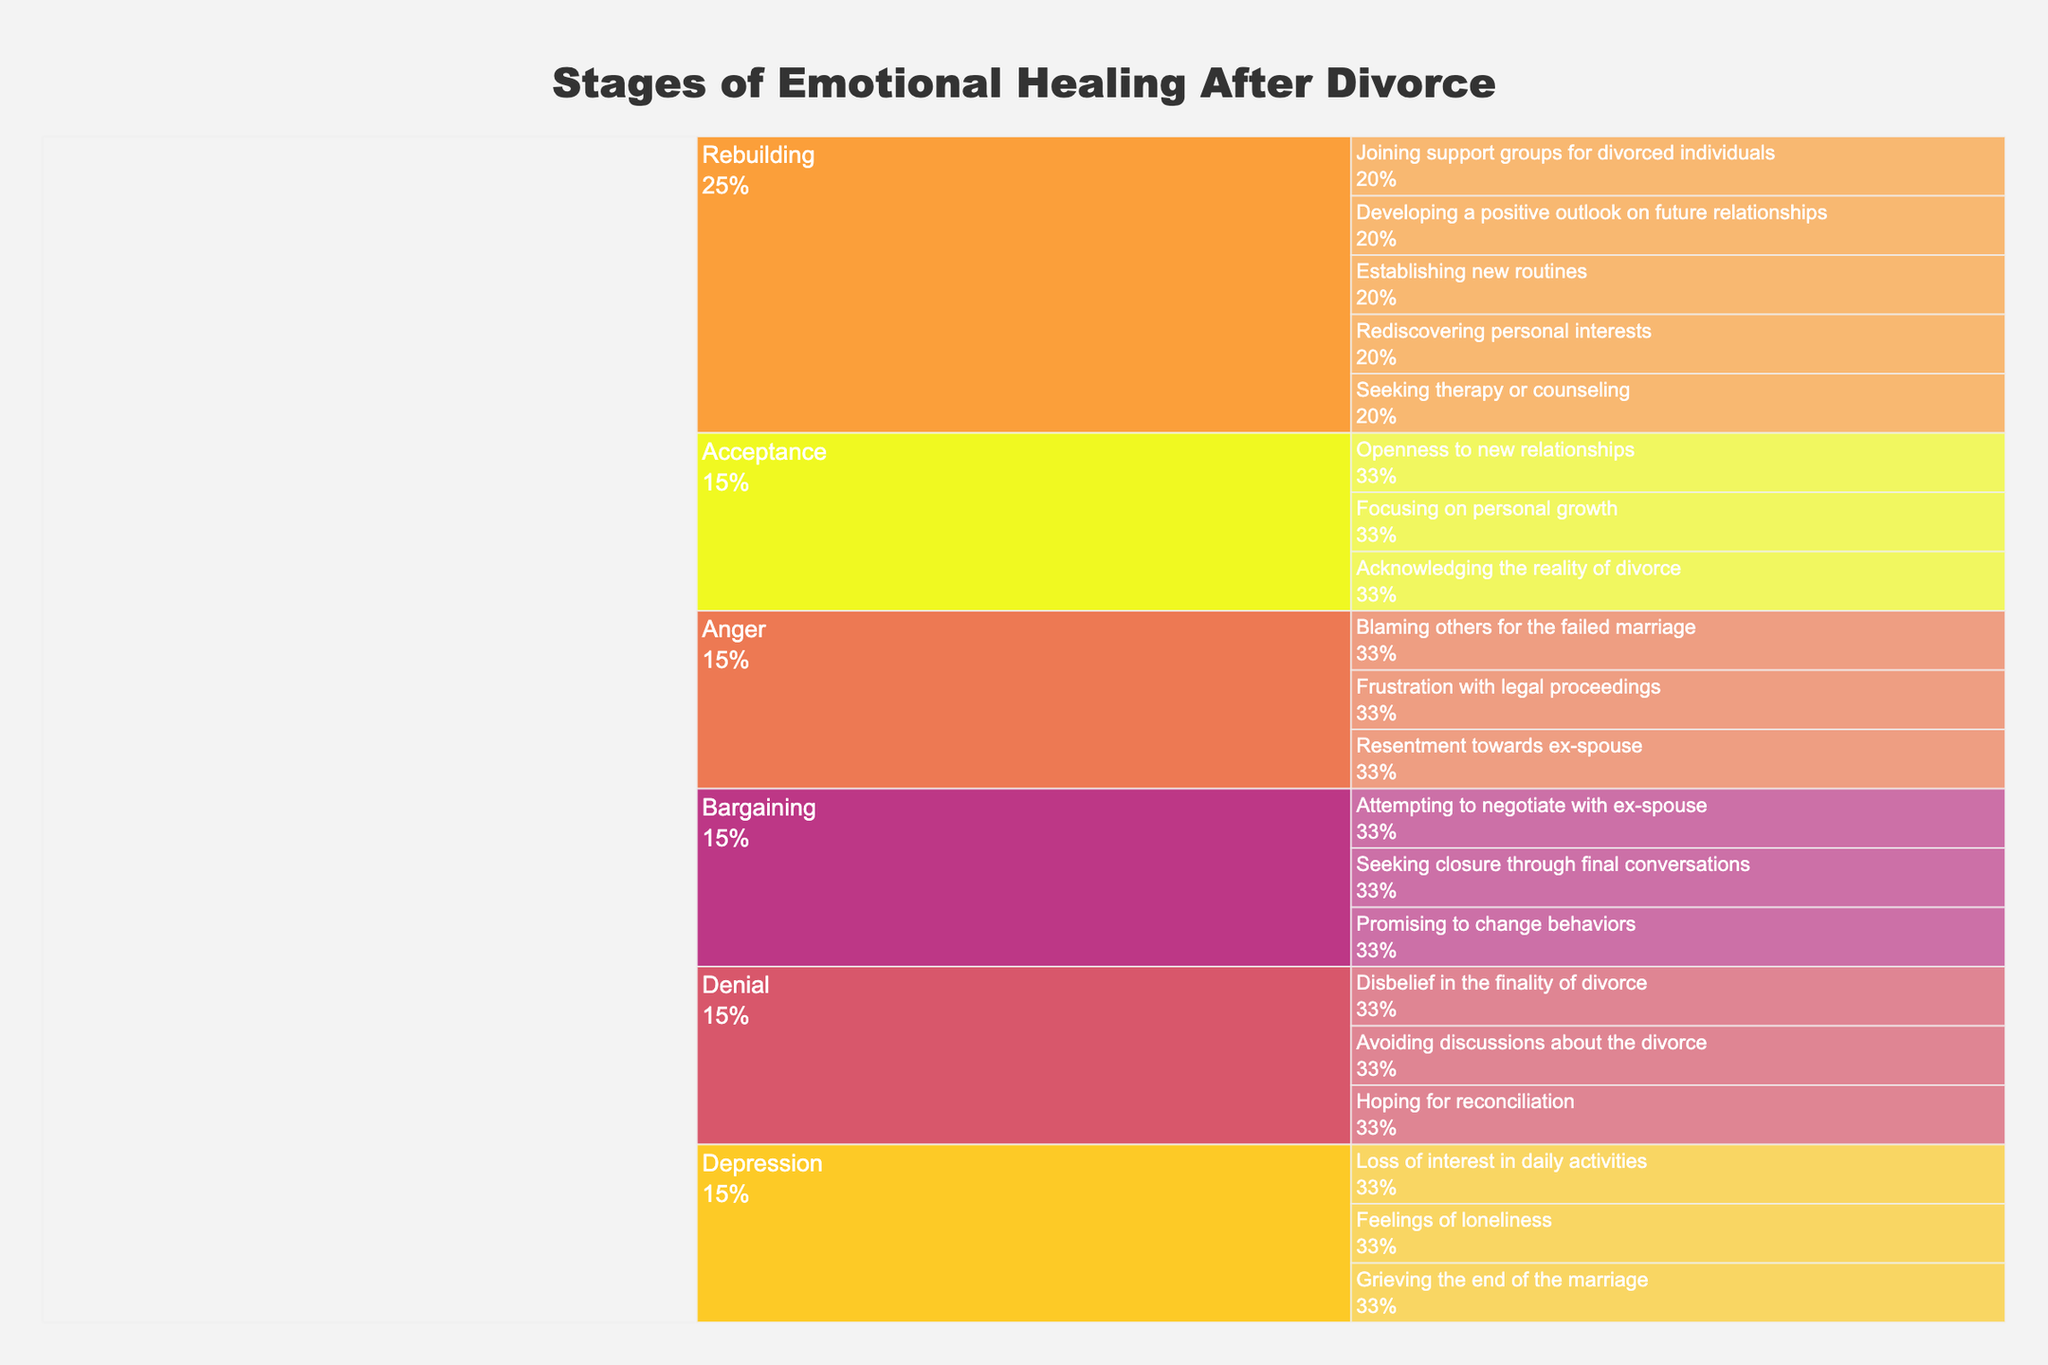How many stages of emotional healing are depicted in this Icicle Chart? The chart has five stages, which are each represented within the first hierarchical level. These stages are Denial, Anger, Bargaining, Depression, Acceptance, and Rebuilding.
Answer: Six What stage includes the experience 'Seeking therapy or counseling'? By visually inspecting the chart and looking for the experience labeled 'Seeking therapy or counseling', we find it under the 'Rebuilding' stage.
Answer: Rebuilding Which stage has the most experiences listed under it? To determine this, we need to count the experiences listed under each stage. Denial has 3, Anger has 3, Bargaining has 3, Depression has 3, Acceptance has 3, and Rebuilding has 5. Thus, the 'Rebuilding' stage contains the most experiences.
Answer: Rebuilding What percentage of experiences fall under the 'Acceptance' stage? The 'Acceptance' stage has 3 experiences. As there are a total of 20 experiences listed, the percentage is calculated as (3/20) * 100%.
Answer: 15% What is the common experience in both 'Anger' and 'Bargaining' stages? By observing the icicle chart's structure, there is no common experience that appears in both 'Anger' and 'Bargaining' stages because each experience is uniquely listed under a single stage.
Answer: None Is 'Feelings of loneliness' more closely related to 'Denial' or 'Depression'? By looking at the hierarchical structure of the icicle chart, 'Feelings of loneliness' falls under the 'Depression' stage, making it more closely related to 'Depression'.
Answer: Depression Between 'Denial' and 'Acceptance', which stage has experiences related to personal growth? The 'Acceptance' stage includes an experience labeled 'Focusing on personal growth'. The 'Denial' stage does not list any experiences related to personal growth.
Answer: Acceptance What stage follows after 'Acceptance' in the hierarchy of emotional healing? The stages are listed in order following the process of emotional healing. After 'Acceptance', the next stage listed is 'Rebuilding'.
Answer: Rebuilding Which stage might involve resuming normal activities based on the experiences listed? The experiences like 'Rediscovering personal interests', 'Establishing new routines', and 'Developing a positive outlook on future relationships' in the 'Rebuilding' stage indicate a phase where one might resume normal activities.
Answer: Rebuilding 